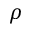Convert formula to latex. <formula><loc_0><loc_0><loc_500><loc_500>\rho</formula> 